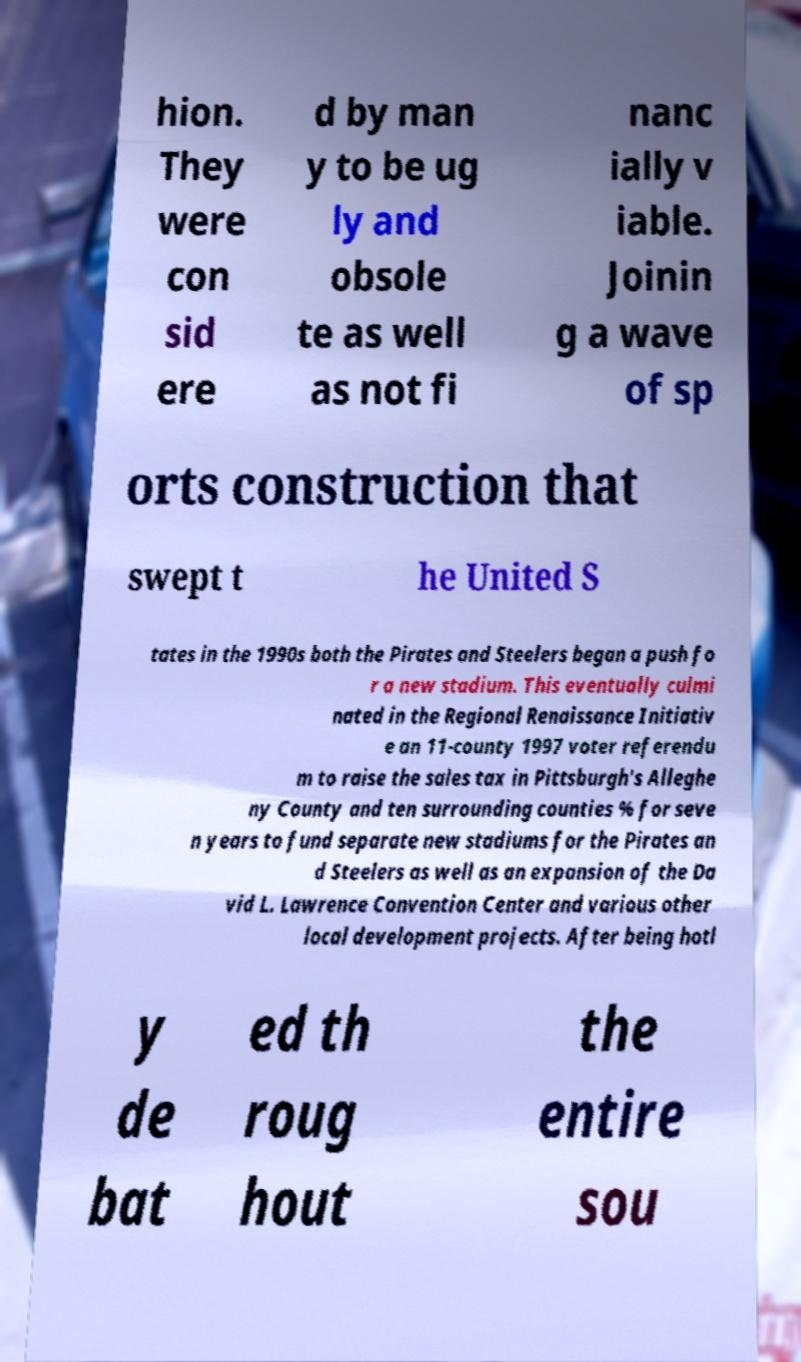What messages or text are displayed in this image? I need them in a readable, typed format. hion. They were con sid ere d by man y to be ug ly and obsole te as well as not fi nanc ially v iable. Joinin g a wave of sp orts construction that swept t he United S tates in the 1990s both the Pirates and Steelers began a push fo r a new stadium. This eventually culmi nated in the Regional Renaissance Initiativ e an 11-county 1997 voter referendu m to raise the sales tax in Pittsburgh's Alleghe ny County and ten surrounding counties % for seve n years to fund separate new stadiums for the Pirates an d Steelers as well as an expansion of the Da vid L. Lawrence Convention Center and various other local development projects. After being hotl y de bat ed th roug hout the entire sou 